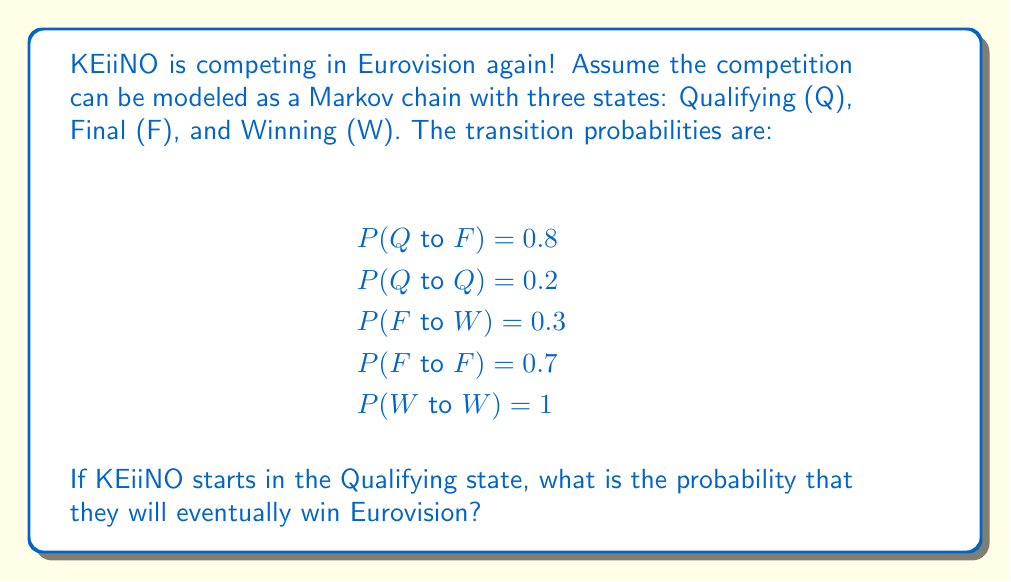Can you solve this math problem? Let's approach this step-by-step using the concept of absorbing Markov chains:

1) First, we identify that the Winning (W) state is an absorbing state, as P(W to W) = 1.

2) We need to calculate the probability of eventually reaching W from Q.

3) Let's define:
   $p_Q$ = probability of eventually reaching W from Q
   $p_F$ = probability of eventually reaching W from F

4) We can set up two equations:

   $p_Q = 0.8p_F + 0.2p_Q$
   $p_F = 0.3 + 0.7p_F$

5) From the second equation:
   $p_F = 0.3 + 0.7p_F$
   $0.3p_F = 0.3$
   $p_F = 1$

6) Substituting this into the first equation:
   $p_Q = 0.8(1) + 0.2p_Q$
   $p_Q = 0.8 + 0.2p_Q$
   $0.8p_Q = 0.8$
   $p_Q = 1$

7) Therefore, starting from the Qualifying state, KEiiNO has a probability of 1 (or 100%) of eventually winning Eurovision according to this Markov chain model.
Answer: 1 